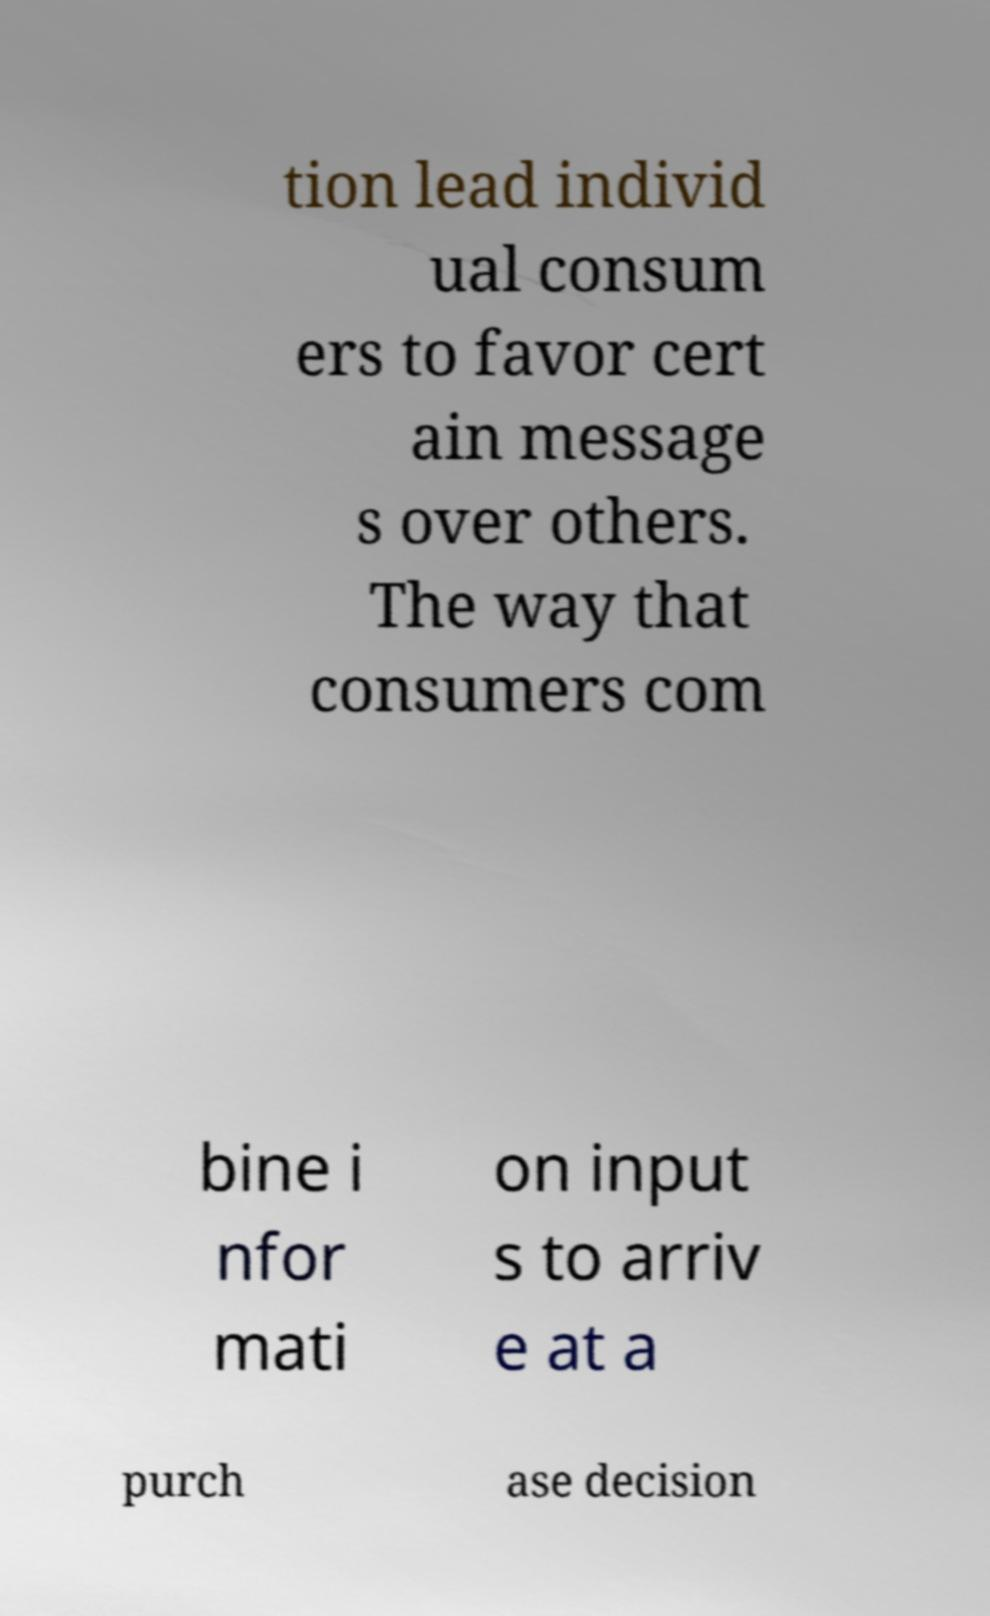Please read and relay the text visible in this image. What does it say? tion lead individ ual consum ers to favor cert ain message s over others. The way that consumers com bine i nfor mati on input s to arriv e at a purch ase decision 